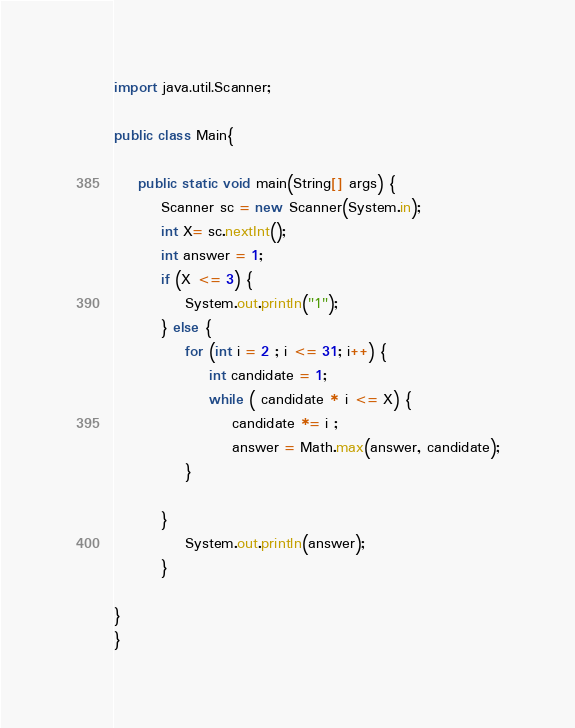<code> <loc_0><loc_0><loc_500><loc_500><_Java_>import java.util.Scanner;

public class Main{

	public static void main(String[] args) {
		Scanner sc = new Scanner(System.in);
		int X= sc.nextInt();
		int answer = 1;
		if (X <= 3) {
			System.out.println("1");
		} else {
			for (int i = 2 ; i <= 31; i++) {
				int candidate = 1;
				while ( candidate * i <= X) {
					candidate *= i ;
					answer = Math.max(answer, candidate);
			}

		}
			System.out.println(answer);
		}

}
}
</code> 